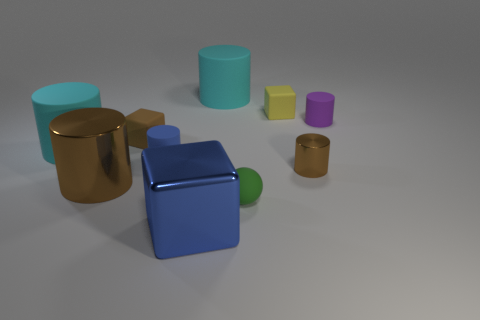Subtract all brown cylinders. How many cylinders are left? 4 Subtract 4 cylinders. How many cylinders are left? 2 Subtract all purple rubber cylinders. How many cylinders are left? 5 Subtract all blue cylinders. Subtract all yellow spheres. How many cylinders are left? 5 Subtract all cylinders. How many objects are left? 4 Add 6 purple things. How many purple things are left? 7 Add 8 large blue spheres. How many large blue spheres exist? 8 Subtract 1 green spheres. How many objects are left? 9 Subtract all tiny rubber things. Subtract all small purple rubber objects. How many objects are left? 4 